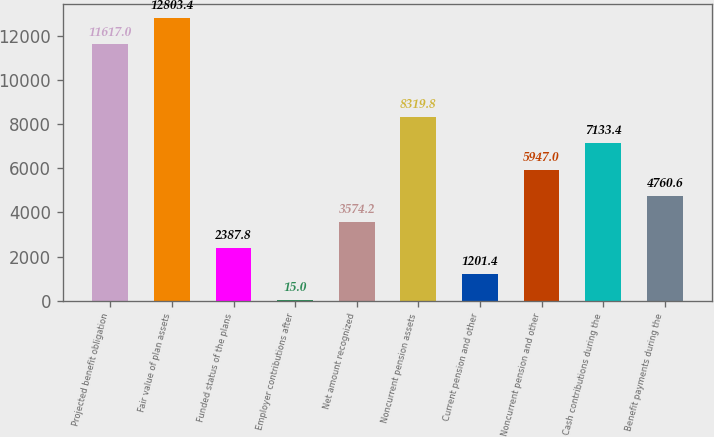Convert chart. <chart><loc_0><loc_0><loc_500><loc_500><bar_chart><fcel>Projected benefit obligation<fcel>Fair value of plan assets<fcel>Funded status of the plans<fcel>Employer contributions after<fcel>Net amount recognized<fcel>Noncurrent pension assets<fcel>Current pension and other<fcel>Noncurrent pension and other<fcel>Cash contributions during the<fcel>Benefit payments during the<nl><fcel>11617<fcel>12803.4<fcel>2387.8<fcel>15<fcel>3574.2<fcel>8319.8<fcel>1201.4<fcel>5947<fcel>7133.4<fcel>4760.6<nl></chart> 